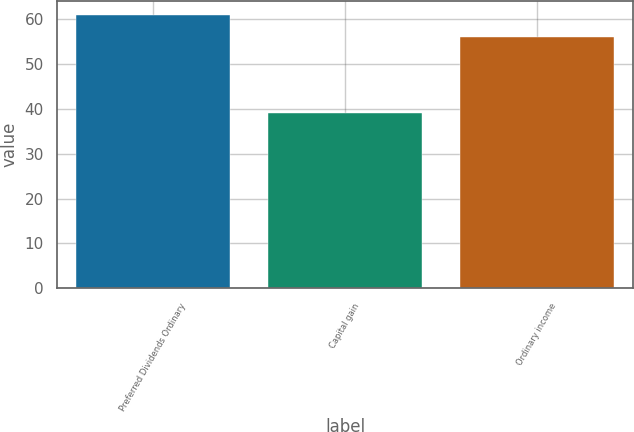<chart> <loc_0><loc_0><loc_500><loc_500><bar_chart><fcel>Preferred Dividends Ordinary<fcel>Capital gain<fcel>Ordinary income<nl><fcel>61<fcel>39<fcel>56<nl></chart> 